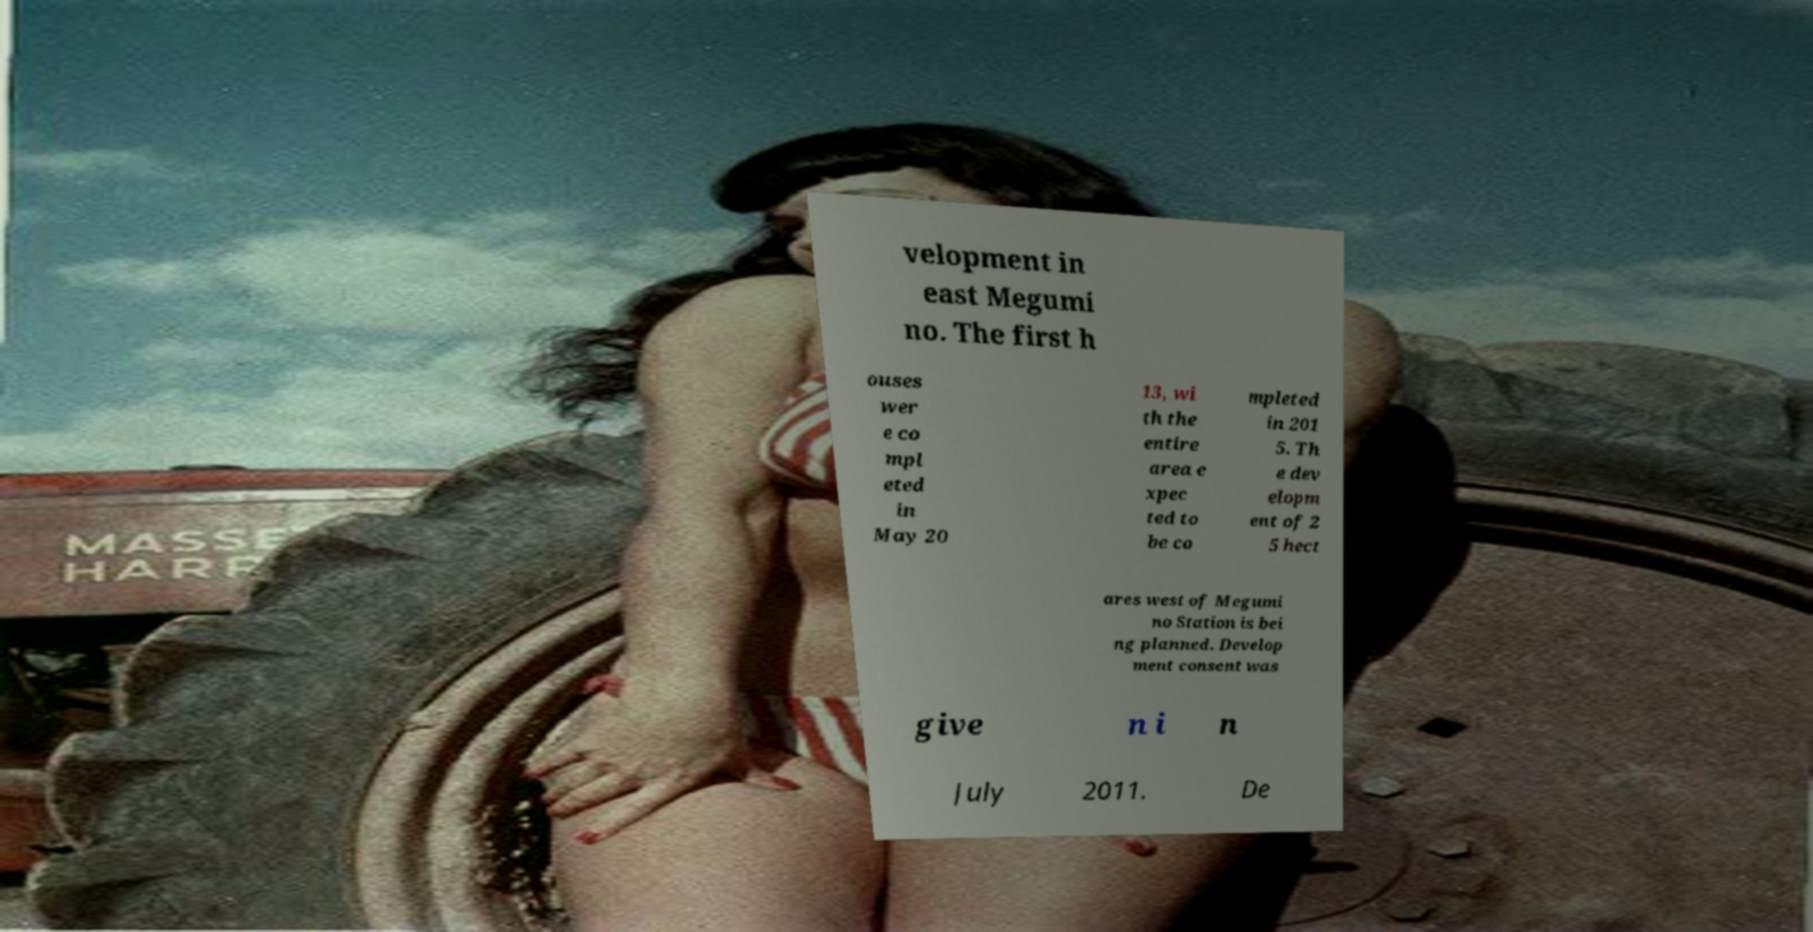Could you extract and type out the text from this image? velopment in east Megumi no. The first h ouses wer e co mpl eted in May 20 13, wi th the entire area e xpec ted to be co mpleted in 201 5. Th e dev elopm ent of 2 5 hect ares west of Megumi no Station is bei ng planned. Develop ment consent was give n i n July 2011. De 